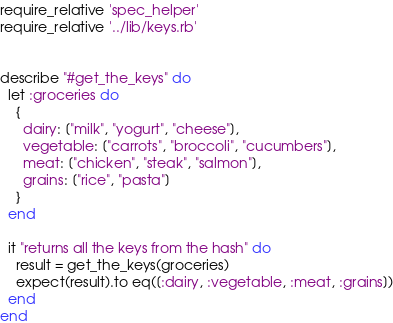Convert code to text. <code><loc_0><loc_0><loc_500><loc_500><_Ruby_>require_relative 'spec_helper'
require_relative '../lib/keys.rb'


describe "#get_the_keys" do
  let :groceries do
    {
      dairy: ["milk", "yogurt", "cheese"],
      vegetable: ["carrots", "broccoli", "cucumbers"],
      meat: ["chicken", "steak", "salmon"],
      grains: ["rice", "pasta"]
    }
  end

  it "returns all the keys from the hash" do
    result = get_the_keys(groceries)
    expect(result).to eq([:dairy, :vegetable, :meat, :grains])
  end
end
</code> 